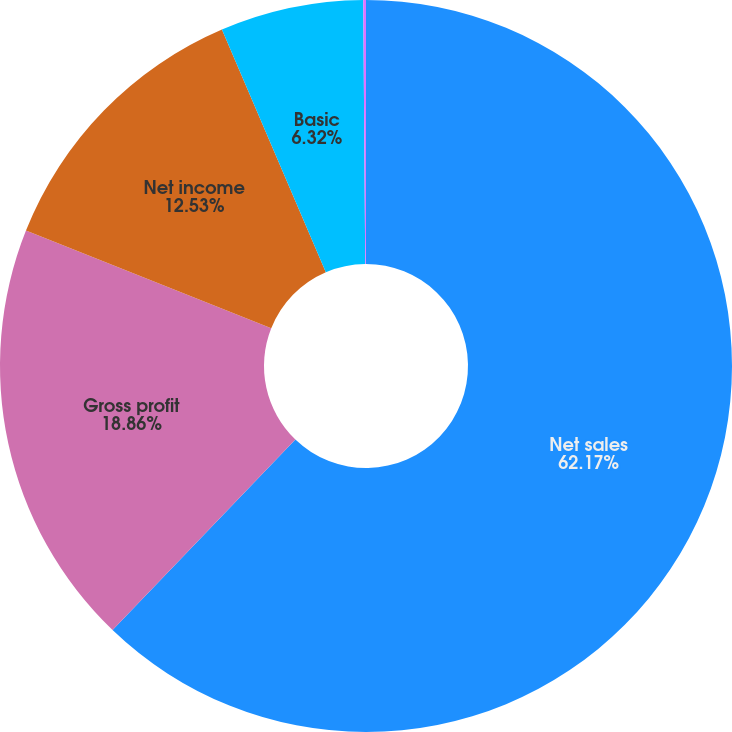Convert chart. <chart><loc_0><loc_0><loc_500><loc_500><pie_chart><fcel>Net sales<fcel>Gross profit<fcel>Net income<fcel>Basic<fcel>Diluted<nl><fcel>62.18%<fcel>18.86%<fcel>12.53%<fcel>6.32%<fcel>0.12%<nl></chart> 